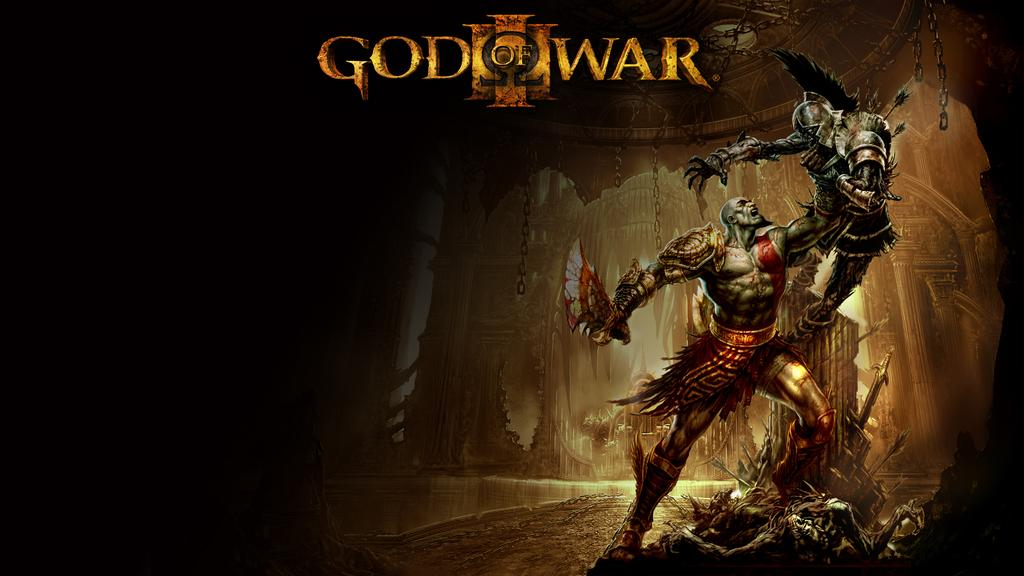How many statues are present in the image? There are two statues in the image. What colors are the statues? The statues are in gray and red colors. What can be seen in the background of the image? There is a building in the background of the image. What is the color of the building? The building is in brown color. Is there any text or writing in the image? Yes, there is something written on the image. How many pigs are present in the image? There are no pigs present in the image. What is the fifth statue in the image? There are only two statues in the image, so there is no fifth statue. 